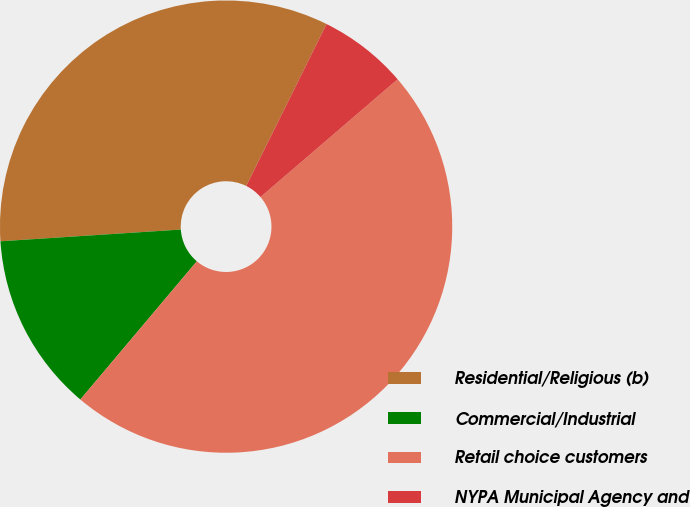<chart> <loc_0><loc_0><loc_500><loc_500><pie_chart><fcel>Residential/Religious (b)<fcel>Commercial/Industrial<fcel>Retail choice customers<fcel>NYPA Municipal Agency and<nl><fcel>33.36%<fcel>12.82%<fcel>47.44%<fcel>6.38%<nl></chart> 